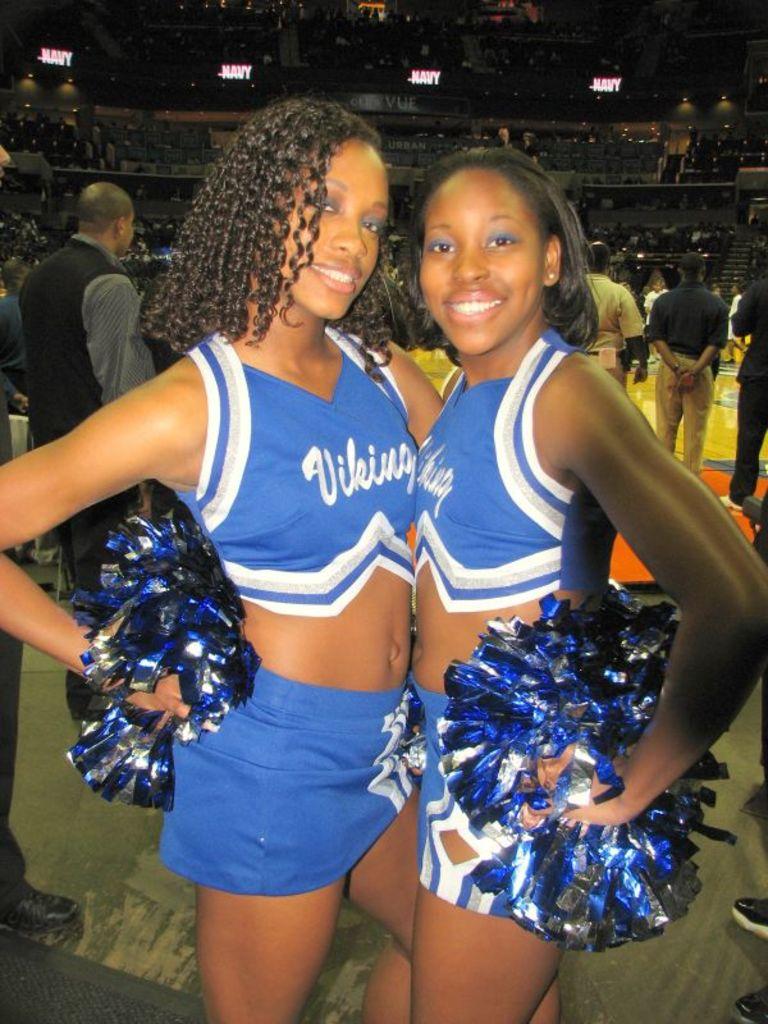What team is this for?
Your response must be concise. Vikings. 